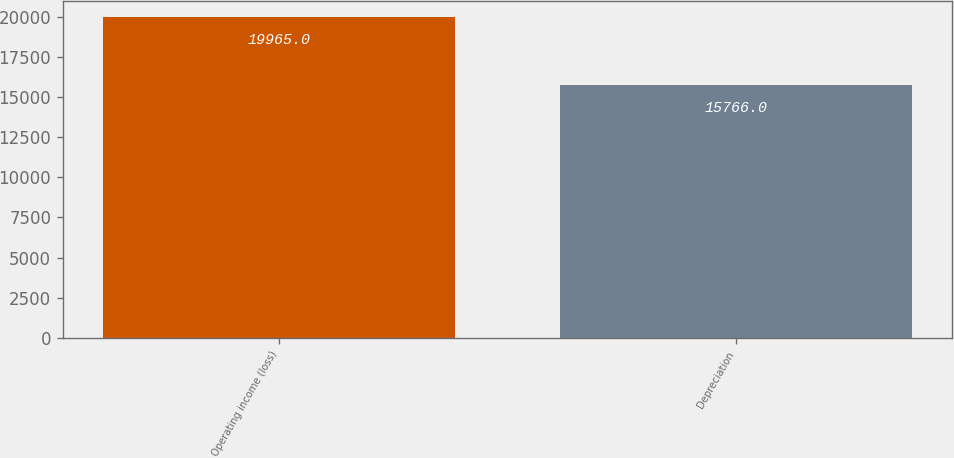Convert chart. <chart><loc_0><loc_0><loc_500><loc_500><bar_chart><fcel>Operating income (loss)<fcel>Depreciation<nl><fcel>19965<fcel>15766<nl></chart> 